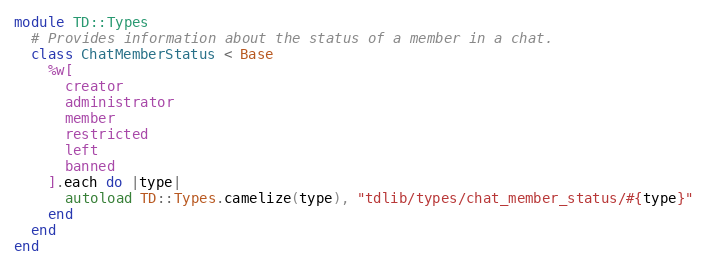Convert code to text. <code><loc_0><loc_0><loc_500><loc_500><_Ruby_>module TD::Types
  # Provides information about the status of a member in a chat.
  class ChatMemberStatus < Base
    %w[
      creator
      administrator
      member
      restricted
      left
      banned
    ].each do |type|
      autoload TD::Types.camelize(type), "tdlib/types/chat_member_status/#{type}"
    end
  end
end
</code> 